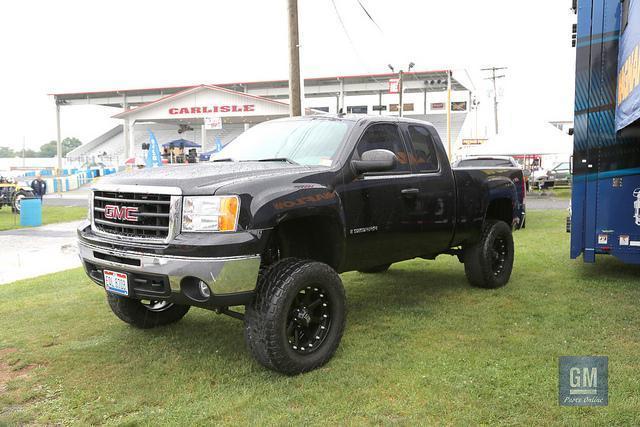How many cylinders does this truck likely have?
Give a very brief answer. 8. How many toilet rolls are reflected in the mirror?
Give a very brief answer. 0. 